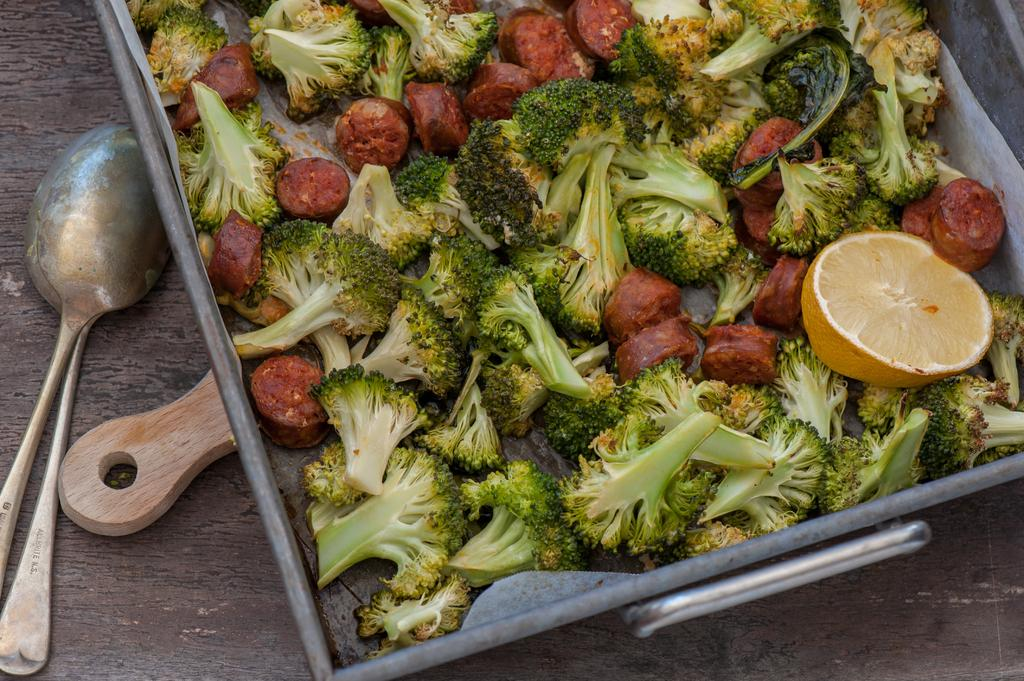What utensils are visible in the image? There are spoons in the image. What type of object can be seen in the image, made of wood? There is a wooden object in the image. What is placed on the wooden surface in the image? There is a tray with food items in the image. On what surface is the tray with food items placed? The tray with food items is placed on a wooden surface. What year is depicted in the image? There is no indication of a specific year in the image. Can you see anyone taking a bath in the image? There is no bath or person taking a bath in the image. 